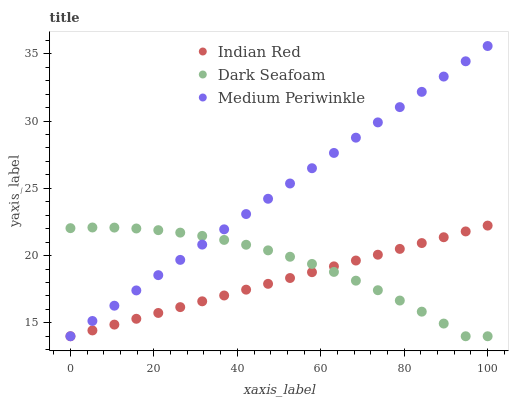Does Indian Red have the minimum area under the curve?
Answer yes or no. Yes. Does Medium Periwinkle have the maximum area under the curve?
Answer yes or no. Yes. Does Medium Periwinkle have the minimum area under the curve?
Answer yes or no. No. Does Indian Red have the maximum area under the curve?
Answer yes or no. No. Is Indian Red the smoothest?
Answer yes or no. Yes. Is Dark Seafoam the roughest?
Answer yes or no. Yes. Is Medium Periwinkle the smoothest?
Answer yes or no. No. Is Medium Periwinkle the roughest?
Answer yes or no. No. Does Dark Seafoam have the lowest value?
Answer yes or no. Yes. Does Medium Periwinkle have the highest value?
Answer yes or no. Yes. Does Indian Red have the highest value?
Answer yes or no. No. Does Indian Red intersect Dark Seafoam?
Answer yes or no. Yes. Is Indian Red less than Dark Seafoam?
Answer yes or no. No. Is Indian Red greater than Dark Seafoam?
Answer yes or no. No. 